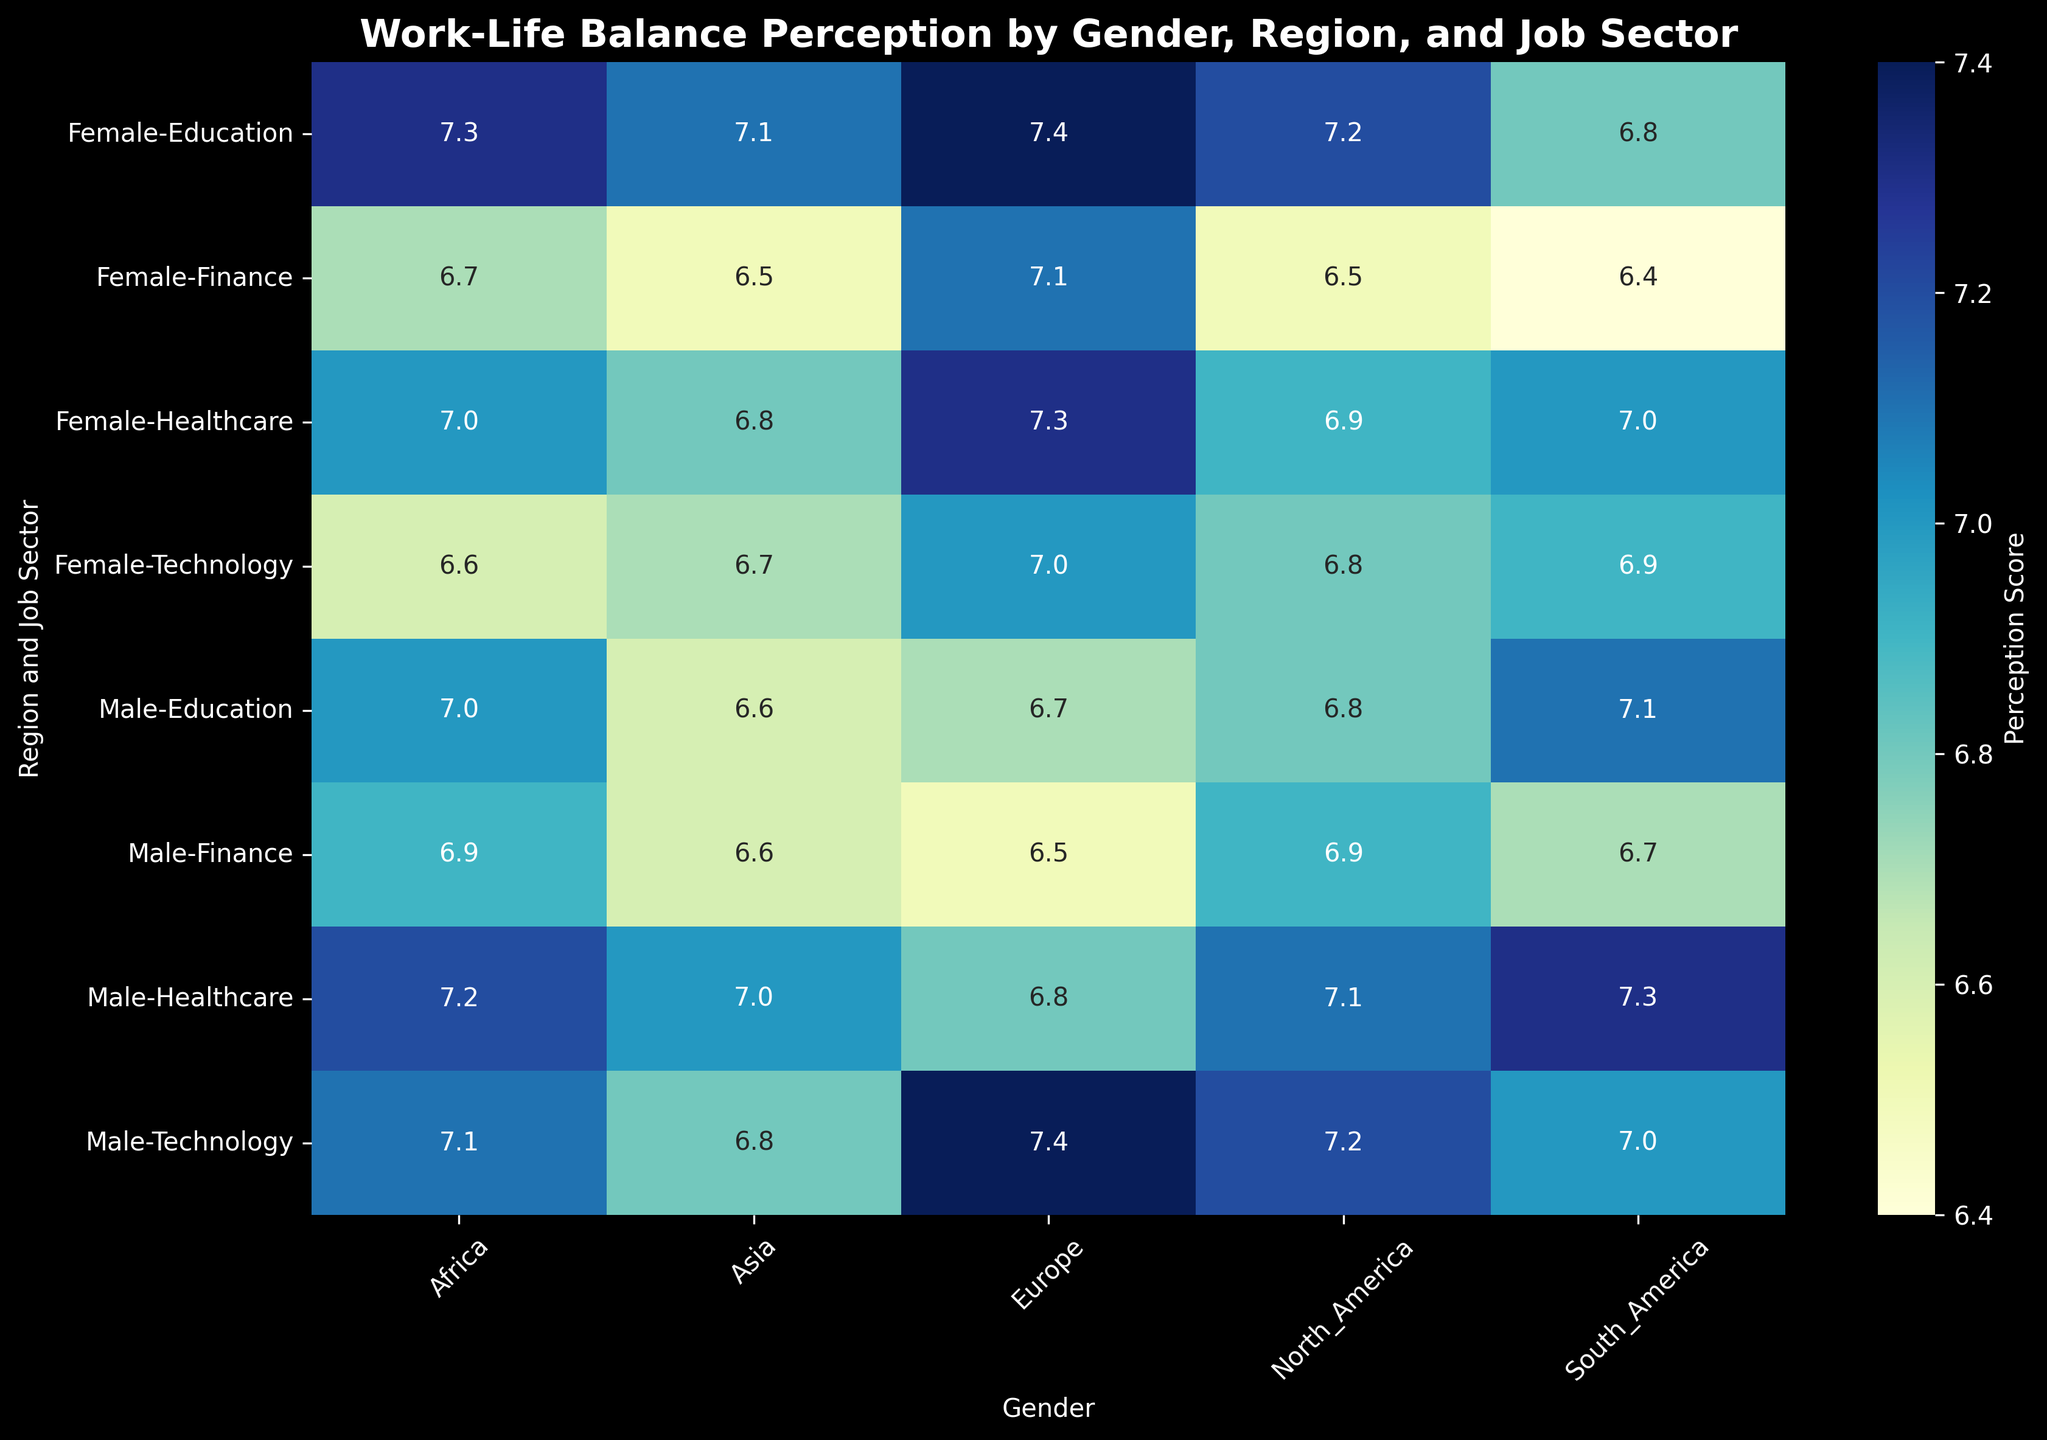Which region and job sector combination shows the highest work-life balance perception for females? Look for the highest numerical value in the female column of the heatmap and note its corresponding region and job sector.
Answer: Europe, Education Which gender has a better work-life balance perception in the healthcare sector in North America? Compare the values between male and female in the healthcare sector in North America.
Answer: Male In Asia, which job sector shows the smallest gender difference in work-life balance perception? Calculate the difference between male and female work-life balance perception scores for each job sector in Asia, and identify the smallest difference.
Answer: Technology (0.1) What's the average work-life balance perception for females across all job sectors in Europe? Find the female scores for all job sectors in Europe (7.0, 7.1, 7.3, 7.4) and calculate their average: \((7.0 + 7.1 + 7.3 + 7.4) / 4 = 7.2\)
Answer: 7.2 Which region has the highest work-life balance perception for technology sector males? Compare the scores of males in the technology sector across different regions.
Answer: Europe Is there any region where females perceive a higher work-life balance in the finance sector compared to males? Compare the male and female scores in the finance sector for each region and identify any region where the female score is higher.
Answer: Europe How does the work-life balance perception of females in the education sector in North America compare to that in South America? Look at the female perception scores in the education sector for North America (7.2) and South America (6.8) and compare them.
Answer: Higher in North America than South America Across all regions, which job sector shows the most uniform work-life balance perception between genders? Calculate the difference between male and female scores for each job sector across all regions, and identify the sector with the smallest average difference.
Answer: Healthcare 